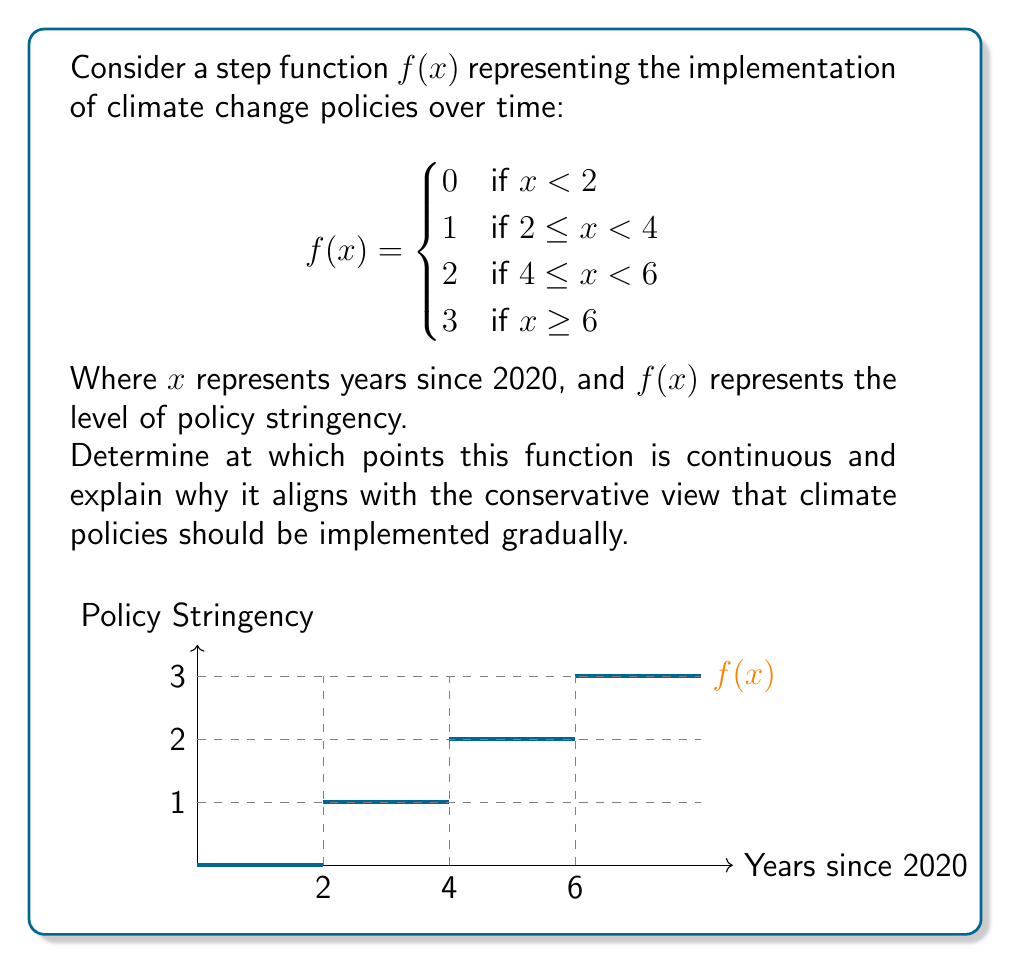Help me with this question. To determine the continuity of this step function, we need to examine each point where the function changes:

1) At $x = 2$:
   $\lim_{x \to 2^-} f(x) = 0$
   $\lim_{x \to 2^+} f(x) = 1$
   $f(2) = 1$
   Since the left-hand limit doesn't equal the right-hand limit, $f(x)$ is discontinuous at $x = 2$.

2) At $x = 4$:
   $\lim_{x \to 4^-} f(x) = 1$
   $\lim_{x \to 4^+} f(x) = 2$
   $f(4) = 2$
   The function is discontinuous at $x = 4$ for the same reason.

3) At $x = 6$:
   $\lim_{x \to 6^-} f(x) = 2$
   $\lim_{x \to 6^+} f(x) = 3$
   $f(6) = 3$
   The function is discontinuous at $x = 6$ as well.

For all other points, the function is continuous as it maintains a constant value within each interval.

This step function aligns with a conservative view on climate policy implementation because:

1) It shows discrete, incremental changes rather than sudden, drastic shifts.
2) There are periods of stability between policy changes, allowing for adjustment.
3) The overall trend is gradual, reflecting a cautious approach to policy implementation.
Answer: $f(x)$ is continuous for all $x$ except at $x = 2$, $x = 4$, and $x = 6$. 